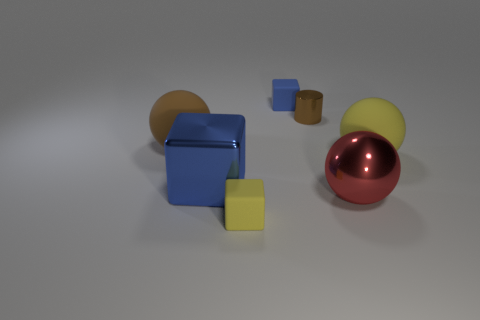There is a big brown object that is the same shape as the red object; what is it made of?
Your answer should be very brief. Rubber. Are there more small green cubes than tiny yellow matte cubes?
Provide a succinct answer. No. There is a metal block; is its color the same as the tiny block in front of the big brown ball?
Your response must be concise. No. There is a large thing that is both right of the large brown sphere and on the left side of the big red metal ball; what is its color?
Make the answer very short. Blue. How many other objects are the same material as the large blue block?
Ensure brevity in your answer.  2. Are there fewer big purple metallic spheres than rubber balls?
Ensure brevity in your answer.  Yes. Do the small brown thing and the small block that is in front of the big metallic ball have the same material?
Give a very brief answer. No. What shape is the big metal object that is behind the large red thing?
Provide a short and direct response. Cube. Are there any other things that are the same color as the cylinder?
Make the answer very short. Yes. Is the number of large spheres that are behind the large blue metallic thing less than the number of large red matte cubes?
Offer a terse response. No. 